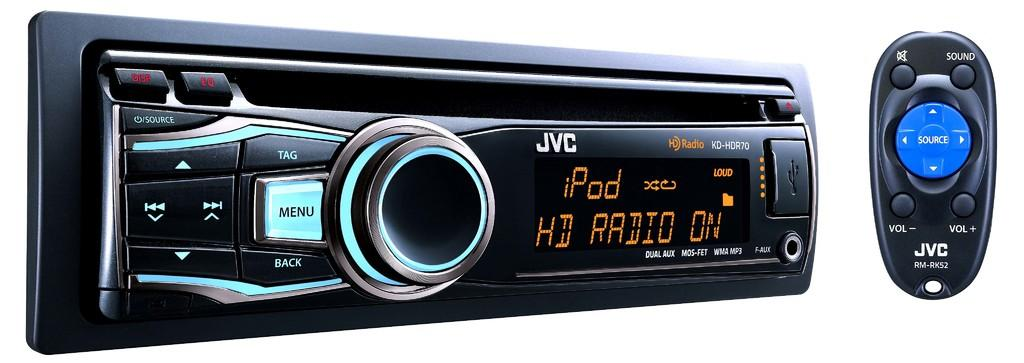<image>
Relay a brief, clear account of the picture shown. The screen of JVC brand radio shows that HD radio is on. 